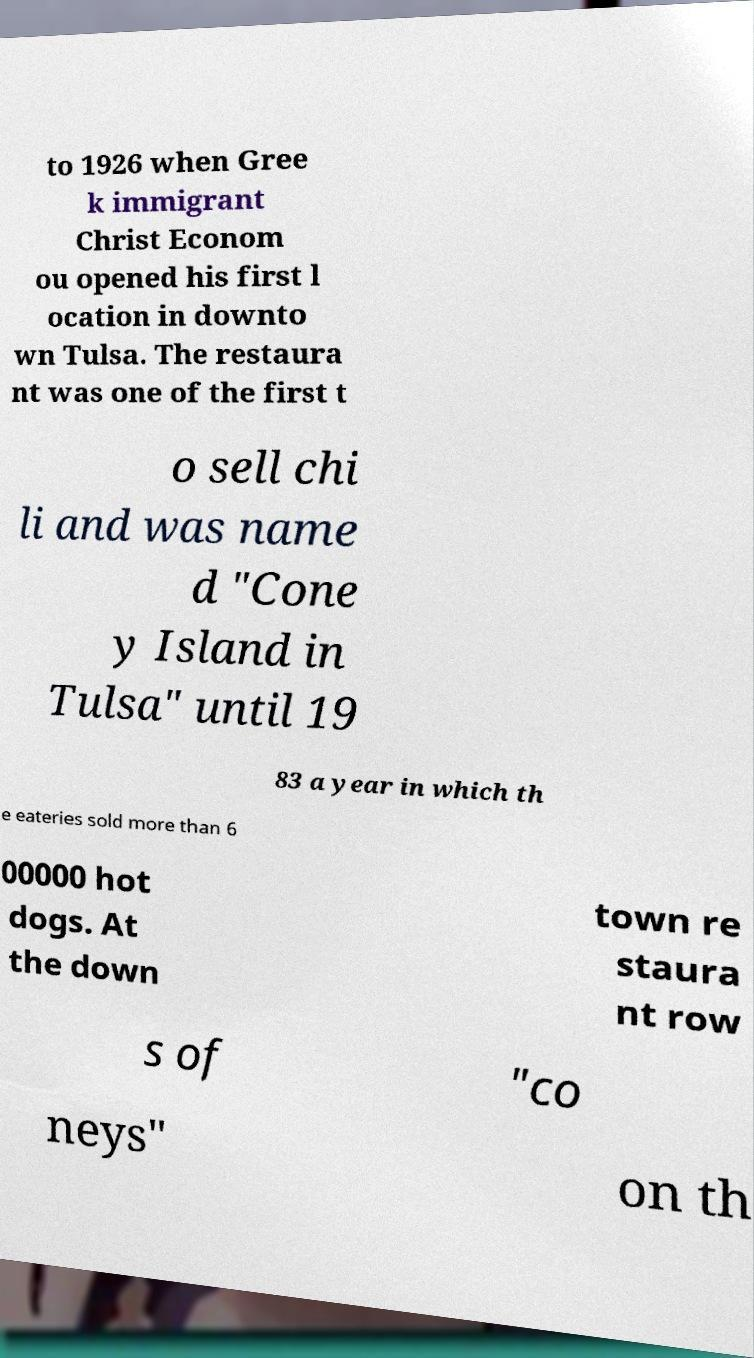I need the written content from this picture converted into text. Can you do that? to 1926 when Gree k immigrant Christ Econom ou opened his first l ocation in downto wn Tulsa. The restaura nt was one of the first t o sell chi li and was name d "Cone y Island in Tulsa" until 19 83 a year in which th e eateries sold more than 6 00000 hot dogs. At the down town re staura nt row s of "co neys" on th 